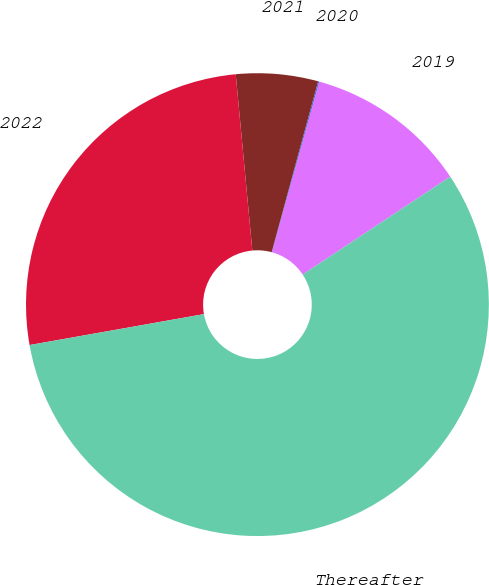Convert chart to OTSL. <chart><loc_0><loc_0><loc_500><loc_500><pie_chart><fcel>2019<fcel>2020<fcel>2021<fcel>2022<fcel>Thereafter<nl><fcel>11.37%<fcel>0.08%<fcel>5.72%<fcel>26.3%<fcel>56.53%<nl></chart> 